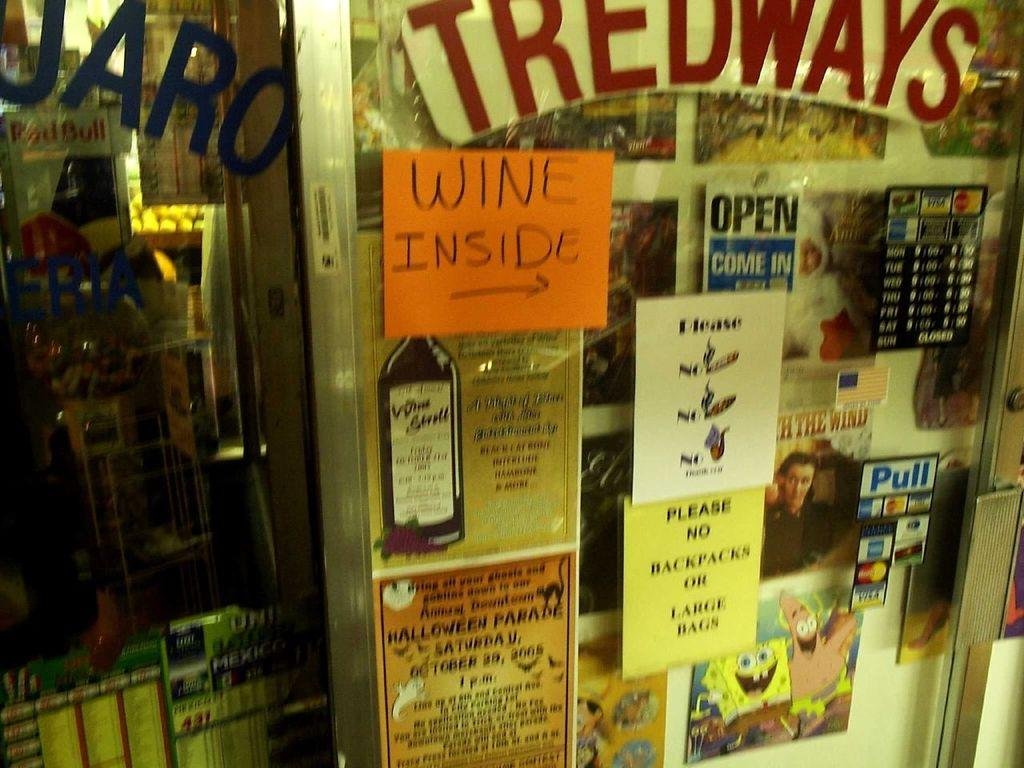<image>
Summarize the visual content of the image. Store front with an orange index card that says "WINE INSIDE". 